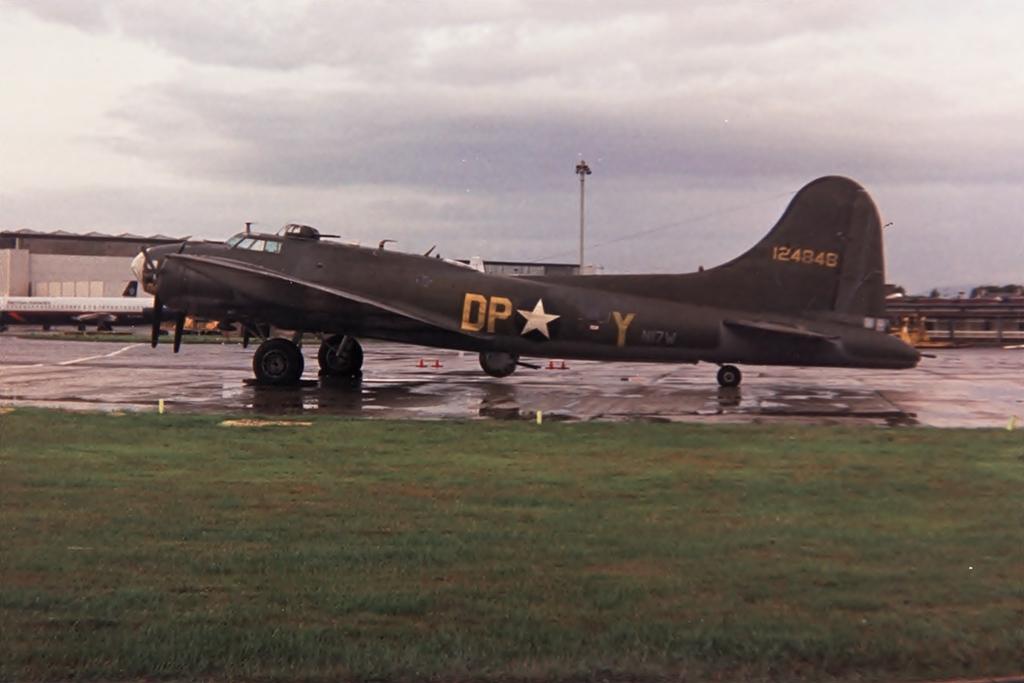What number is the jet?
Your answer should be very brief. 124848. What two letters on to the left of the star?
Ensure brevity in your answer.  Dp. 